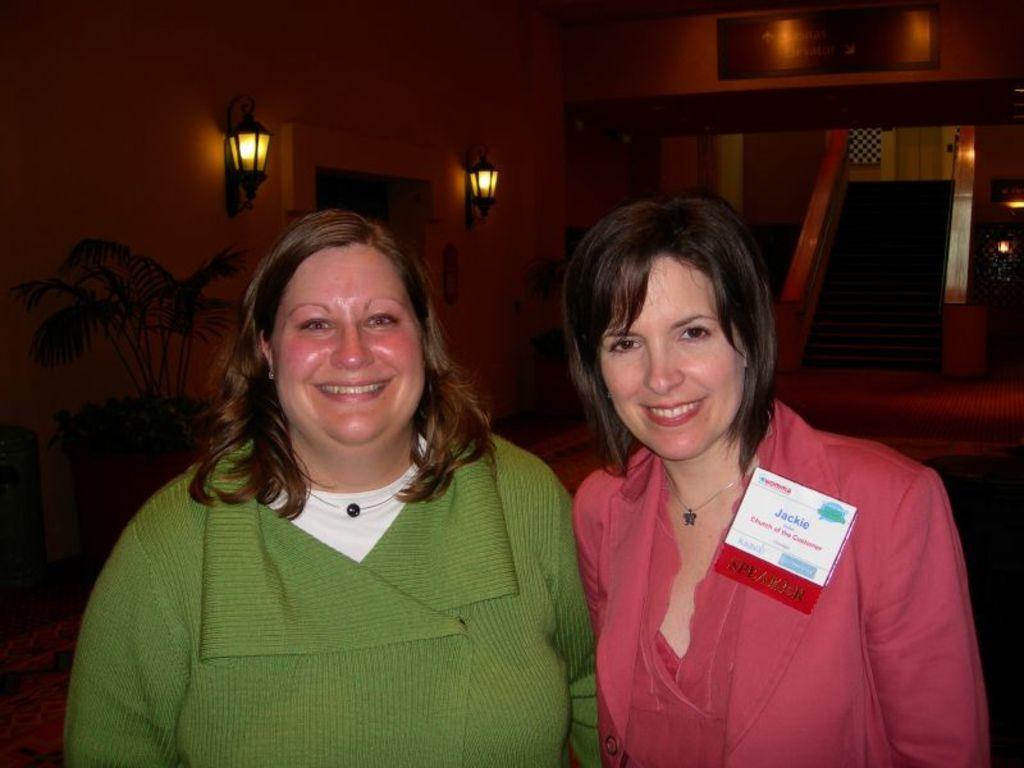Describe this image in one or two sentences. In this image we can see there are two people standing and at the back we can see the frame and lights attached to the wall. And there are stairs and potted plant. 